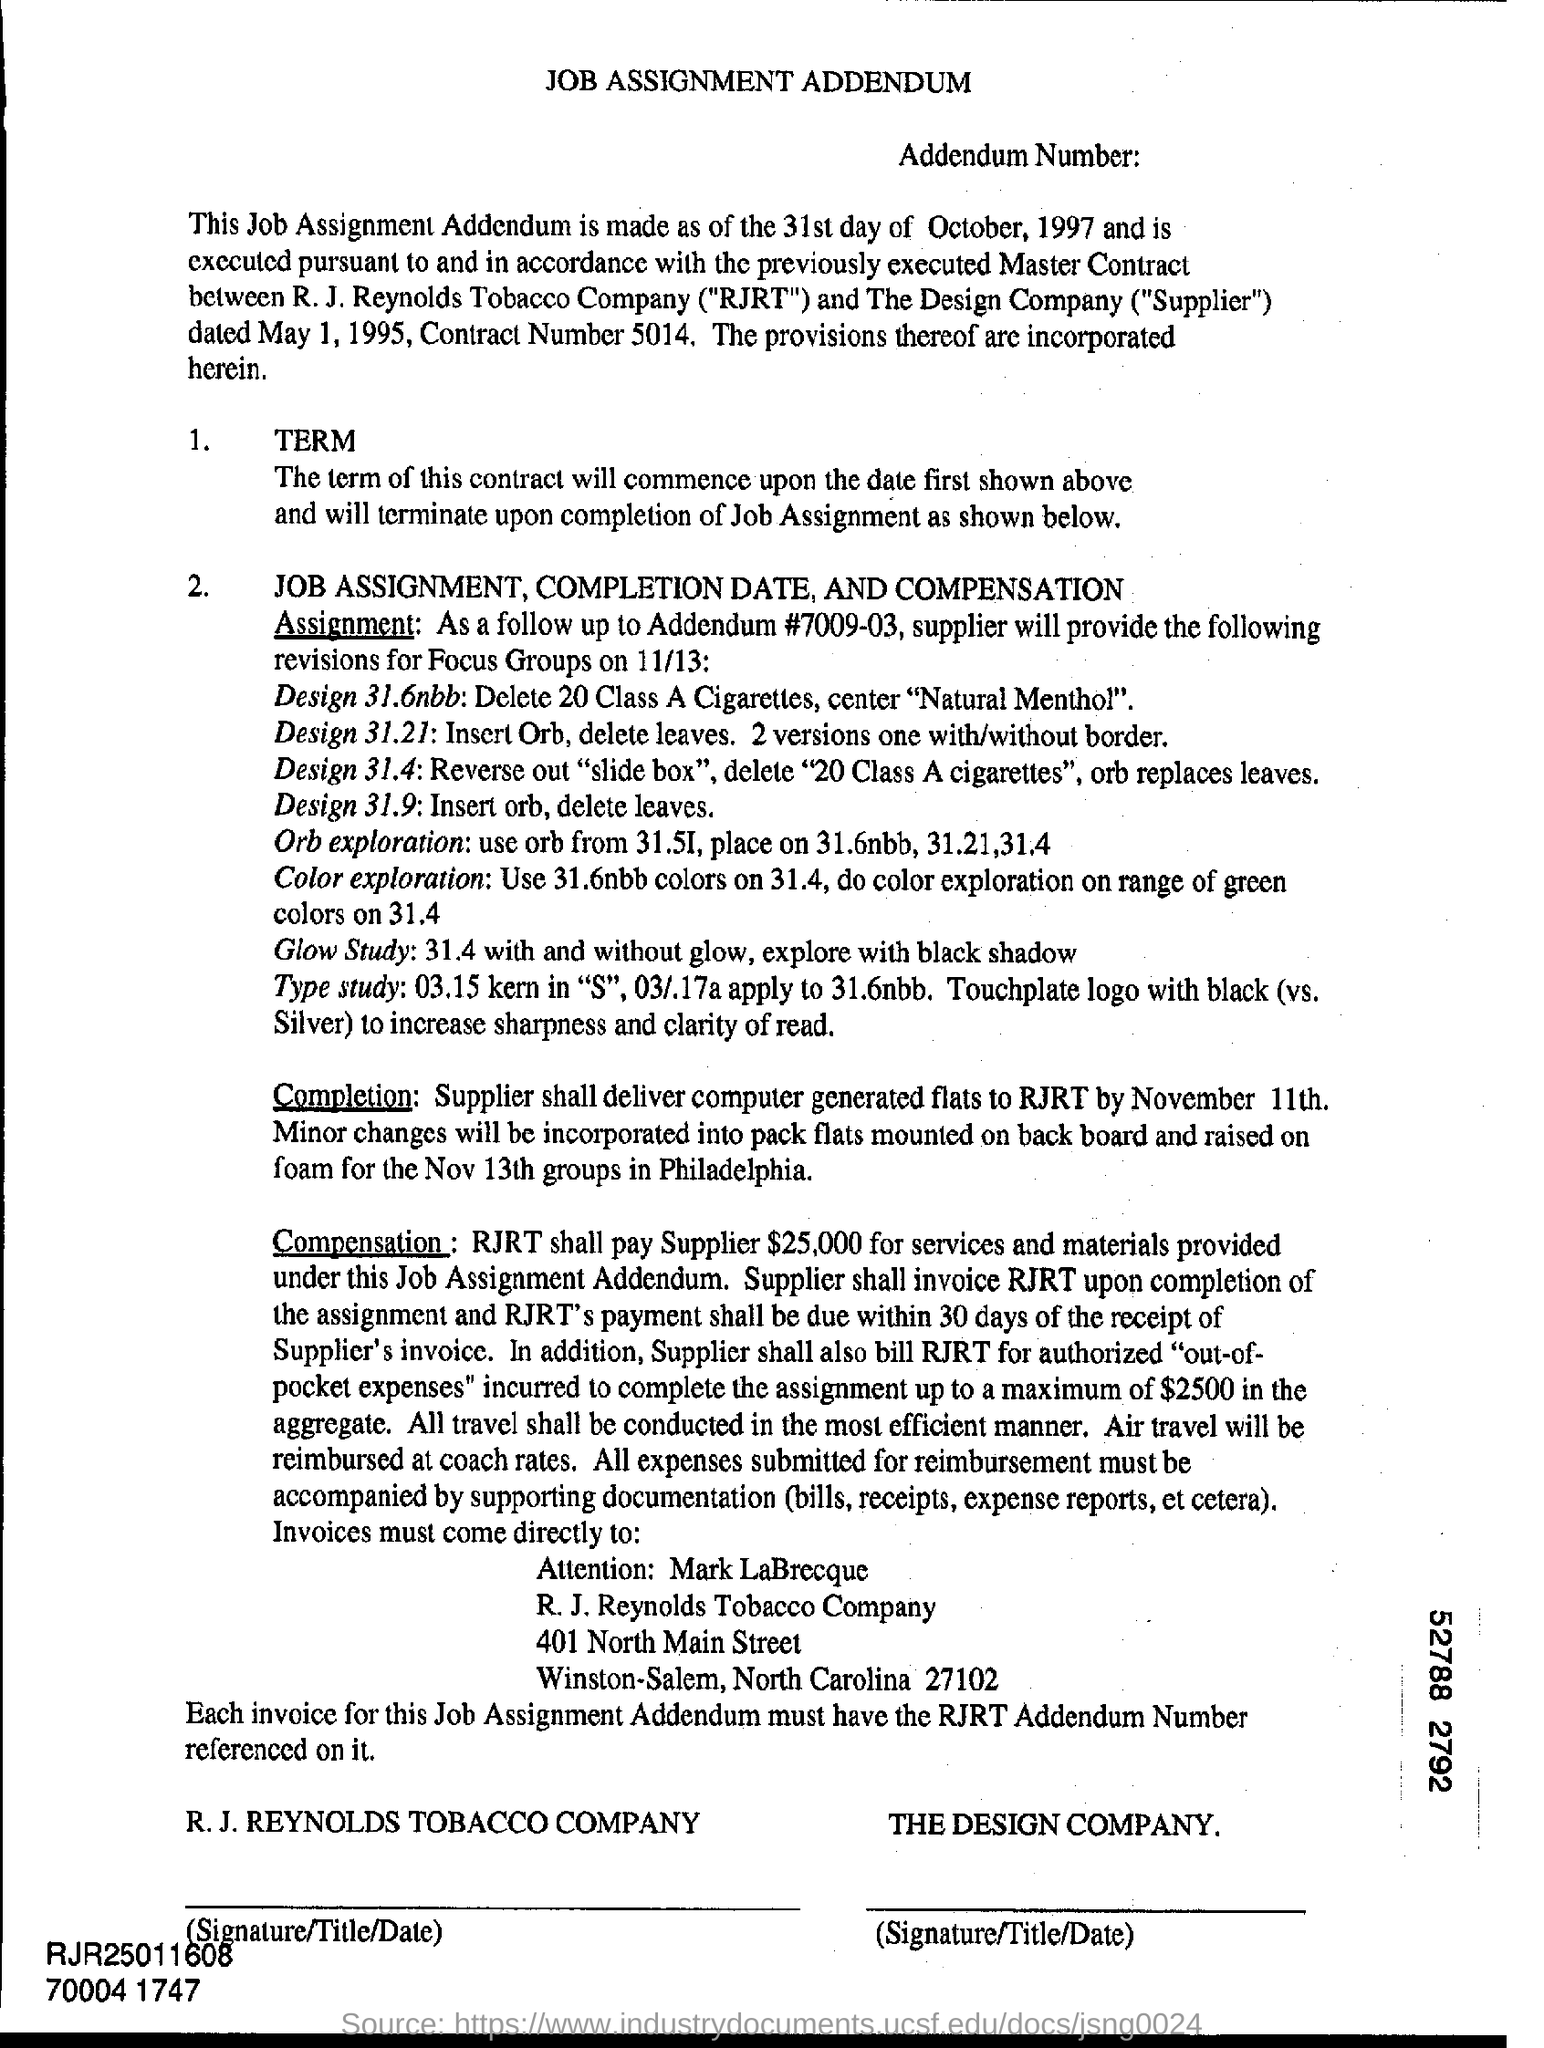What does rjrt stands for ?
Your answer should be very brief. R.J. Reynolds Tobacco Company. What is the contract number ?
Ensure brevity in your answer.  5014. In which state is r.j reynolds tobacco company at ?
Offer a terse response. North Carolina. How much shall rjrt shall pay supplier for services and materials provided under this job assignment addendum ?
Give a very brief answer. $25,000. Who is the "supplier"?
Offer a very short reply. The design company. 